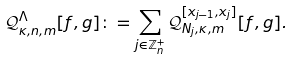Convert formula to latex. <formula><loc_0><loc_0><loc_500><loc_500>\mathcal { Q } ^ { \Lambda } _ { \kappa , n , m } [ f , g ] \colon = \sum _ { j \in \mathbb { Z } _ { n } ^ { + } } \mathcal { Q } _ { N _ { j } , \kappa , m } ^ { [ x _ { j - 1 } , x _ { j } ] } [ f , g ] .</formula> 